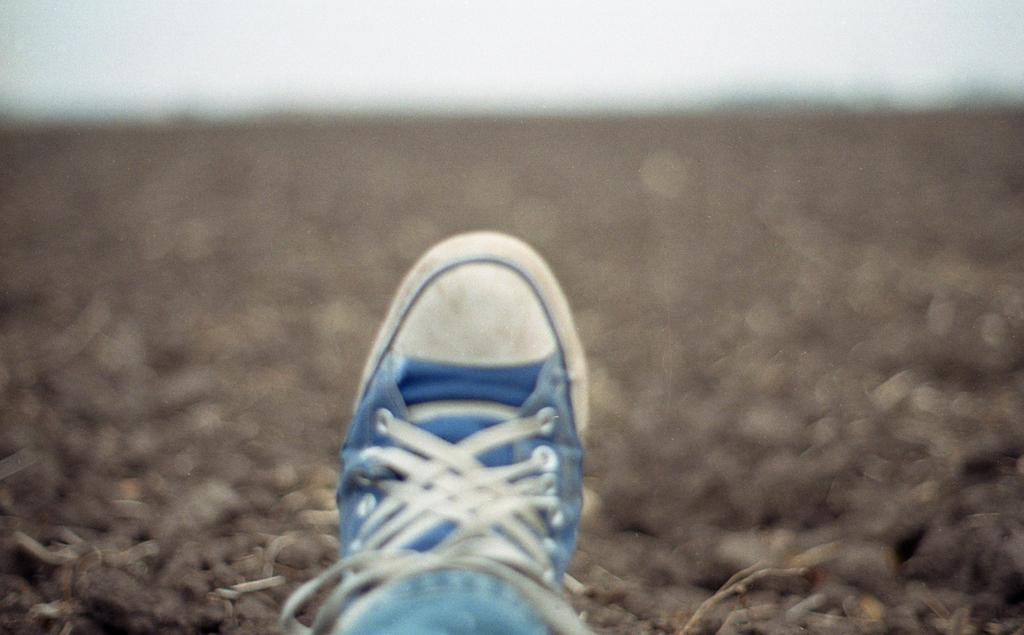In one or two sentences, can you explain what this image depicts? In this I can see a human leg work, trouser, shoe and this is the sand. 